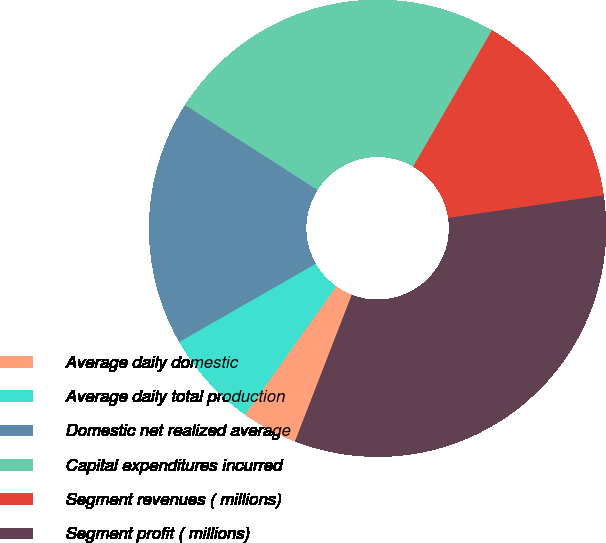<chart> <loc_0><loc_0><loc_500><loc_500><pie_chart><fcel>Average daily domestic<fcel>Average daily total production<fcel>Domestic net realized average<fcel>Capital expenditures incurred<fcel>Segment revenues ( millions)<fcel>Segment profit ( millions)<nl><fcel>3.96%<fcel>6.88%<fcel>17.34%<fcel>24.27%<fcel>14.36%<fcel>33.18%<nl></chart> 